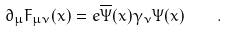<formula> <loc_0><loc_0><loc_500><loc_500>\partial _ { \mu } F _ { \mu \nu } ( x ) = e \overline { \Psi } ( x ) \gamma _ { \nu } \Psi ( x ) \quad .</formula> 